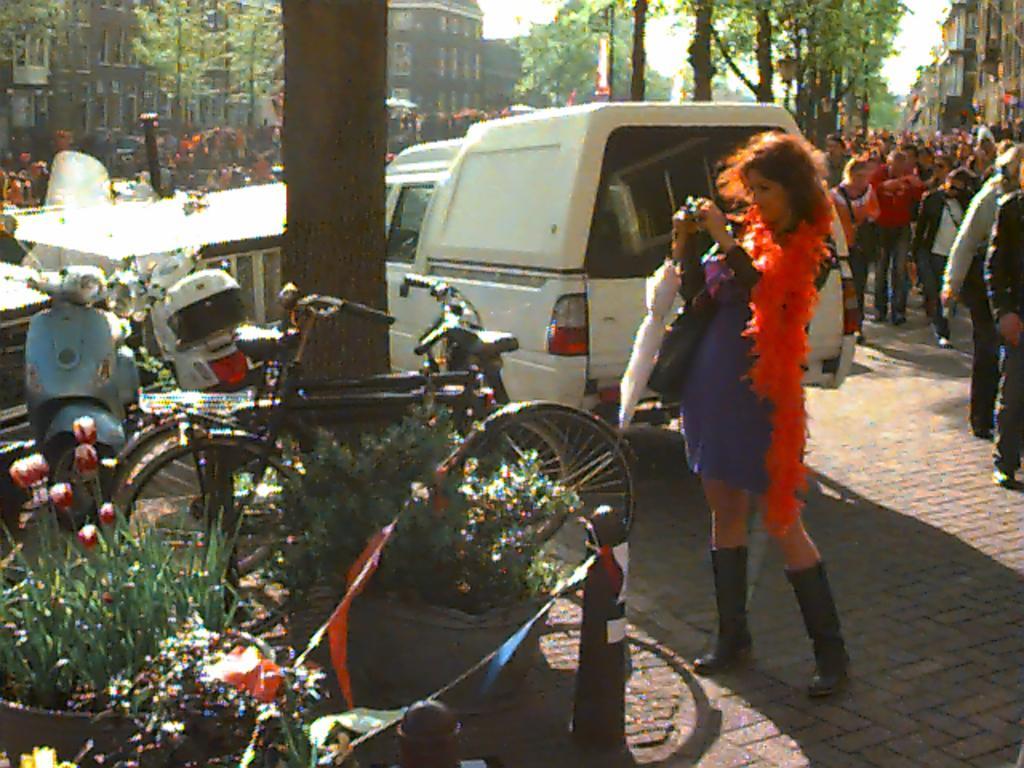In one or two sentences, can you explain what this image depicts? In this image I can see some people. On the left side I can see the vehicles. In the background, I can see the trees and the buildings. 